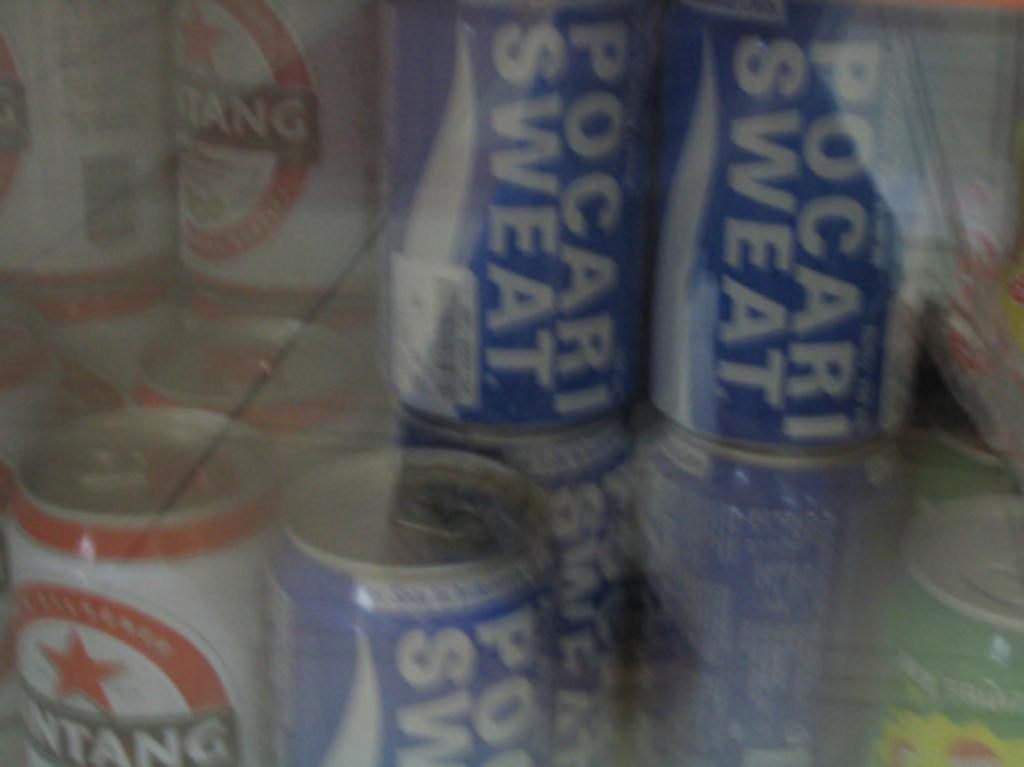<image>
Write a terse but informative summary of the picture. Blurry image of pocari sweat and some other canned beverages. 